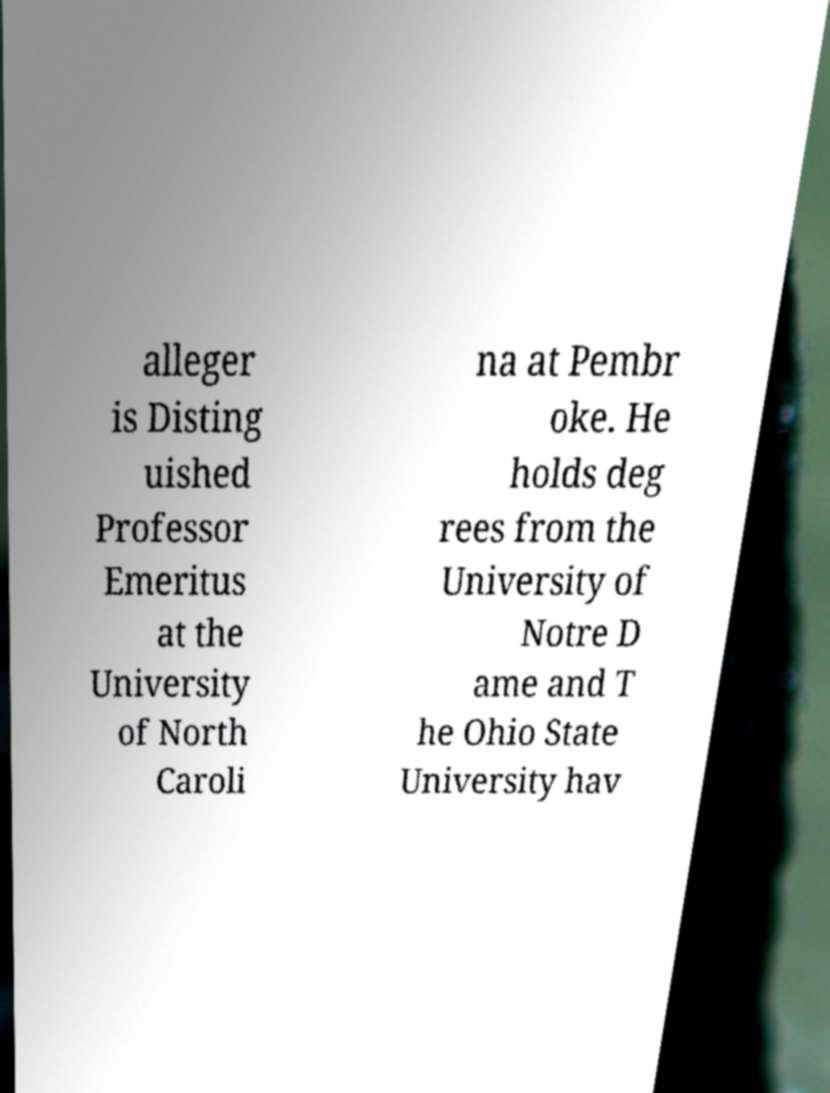What messages or text are displayed in this image? I need them in a readable, typed format. alleger is Disting uished Professor Emeritus at the University of North Caroli na at Pembr oke. He holds deg rees from the University of Notre D ame and T he Ohio State University hav 